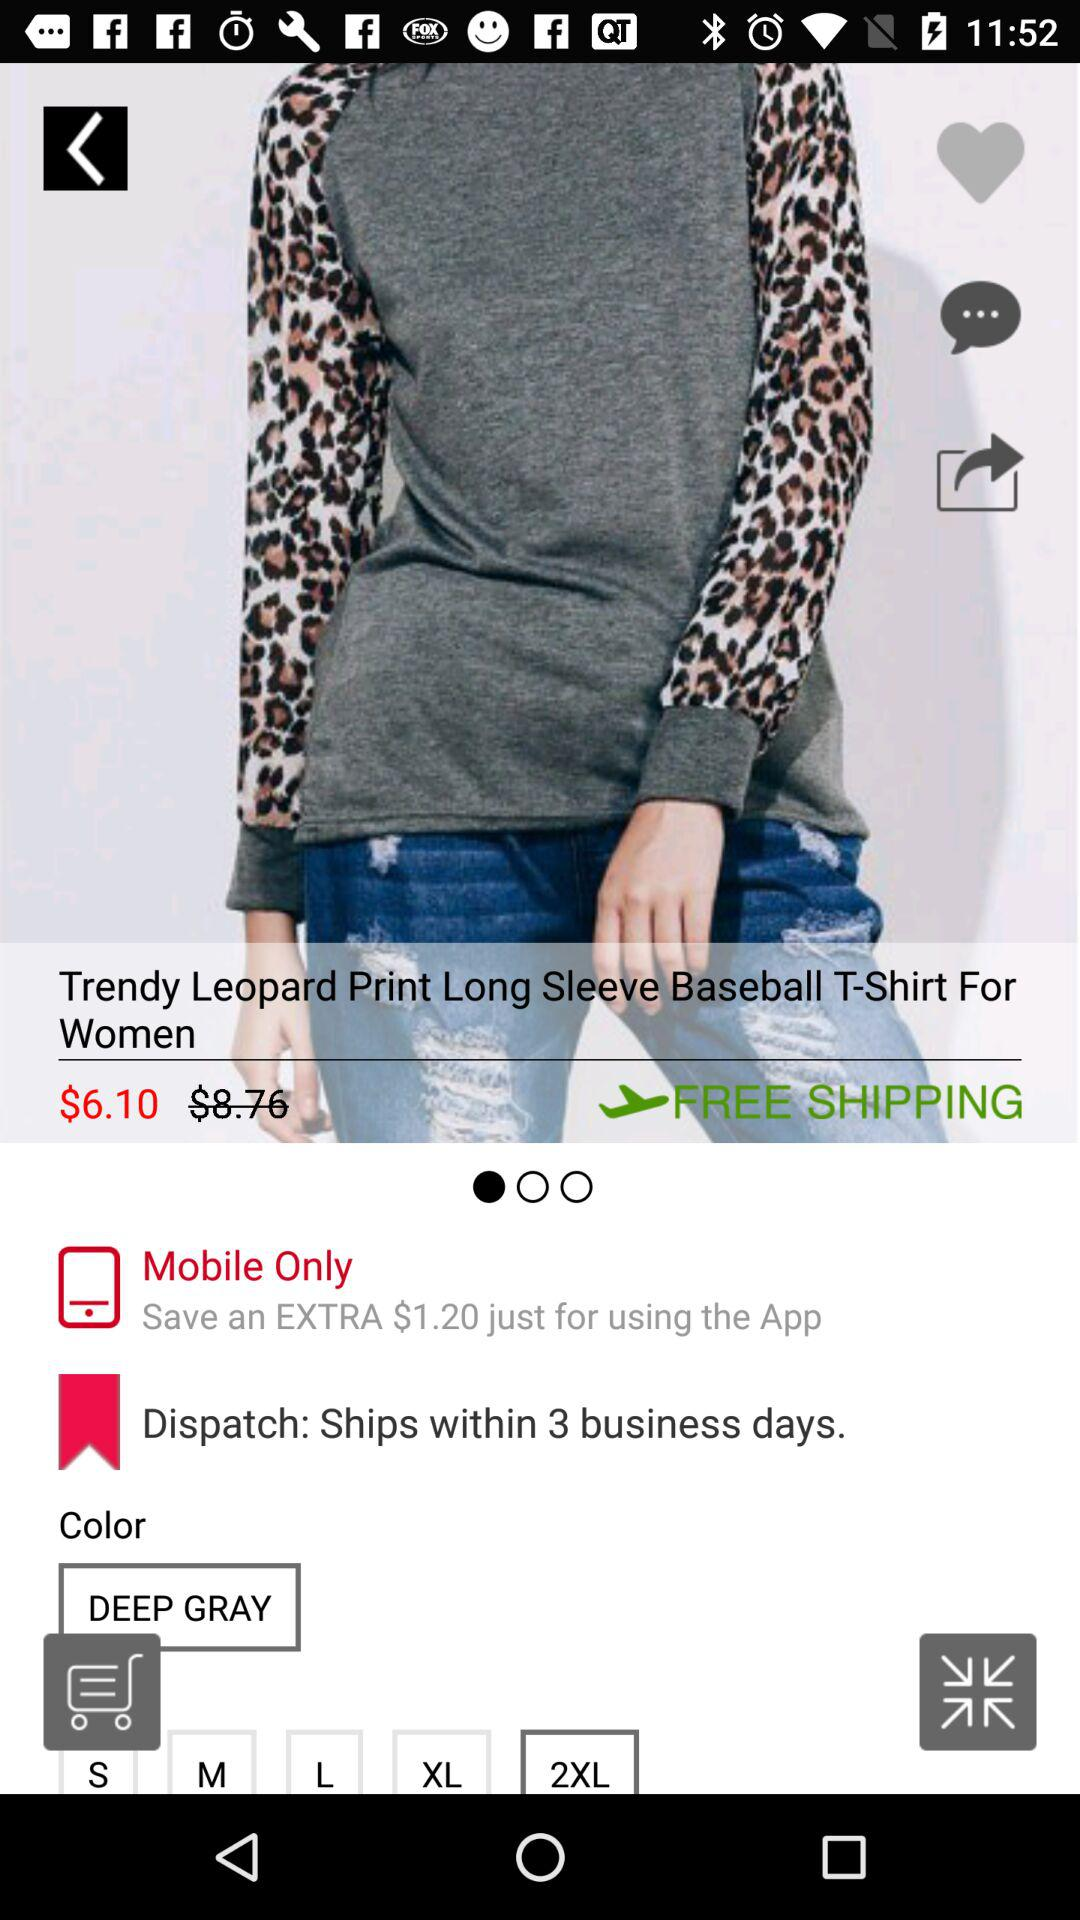Which size is selected? The selected size is "2XL". 